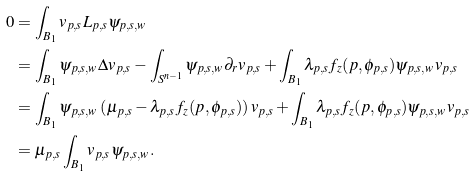Convert formula to latex. <formula><loc_0><loc_0><loc_500><loc_500>0 & = \int _ { B _ { 1 } } v _ { p , s } L _ { p , s } \psi _ { p , s , w } \\ & = \int _ { B _ { 1 } } \psi _ { p , s , w } \Delta v _ { p , s } - \int _ { S ^ { n - 1 } } \psi _ { p , s , w } \partial _ { r } v _ { p , s } + \int _ { B _ { 1 } } \lambda _ { p , s } f _ { z } ( p , \phi _ { p , s } ) \psi _ { p , s , w } v _ { p , s } \\ & = \int _ { B _ { 1 } } \psi _ { p , s , w } \left ( \mu _ { p , s } - \lambda _ { p , s } f _ { z } ( p , \phi _ { p , s } ) \right ) v _ { p , s } + \int _ { B _ { 1 } } \lambda _ { p , s } f _ { z } ( p , \phi _ { p , s } ) \psi _ { p , s , w } v _ { p , s } \\ & = \mu _ { p , s } \int _ { B _ { 1 } } v _ { p , s } \psi _ { p , s , w } .</formula> 